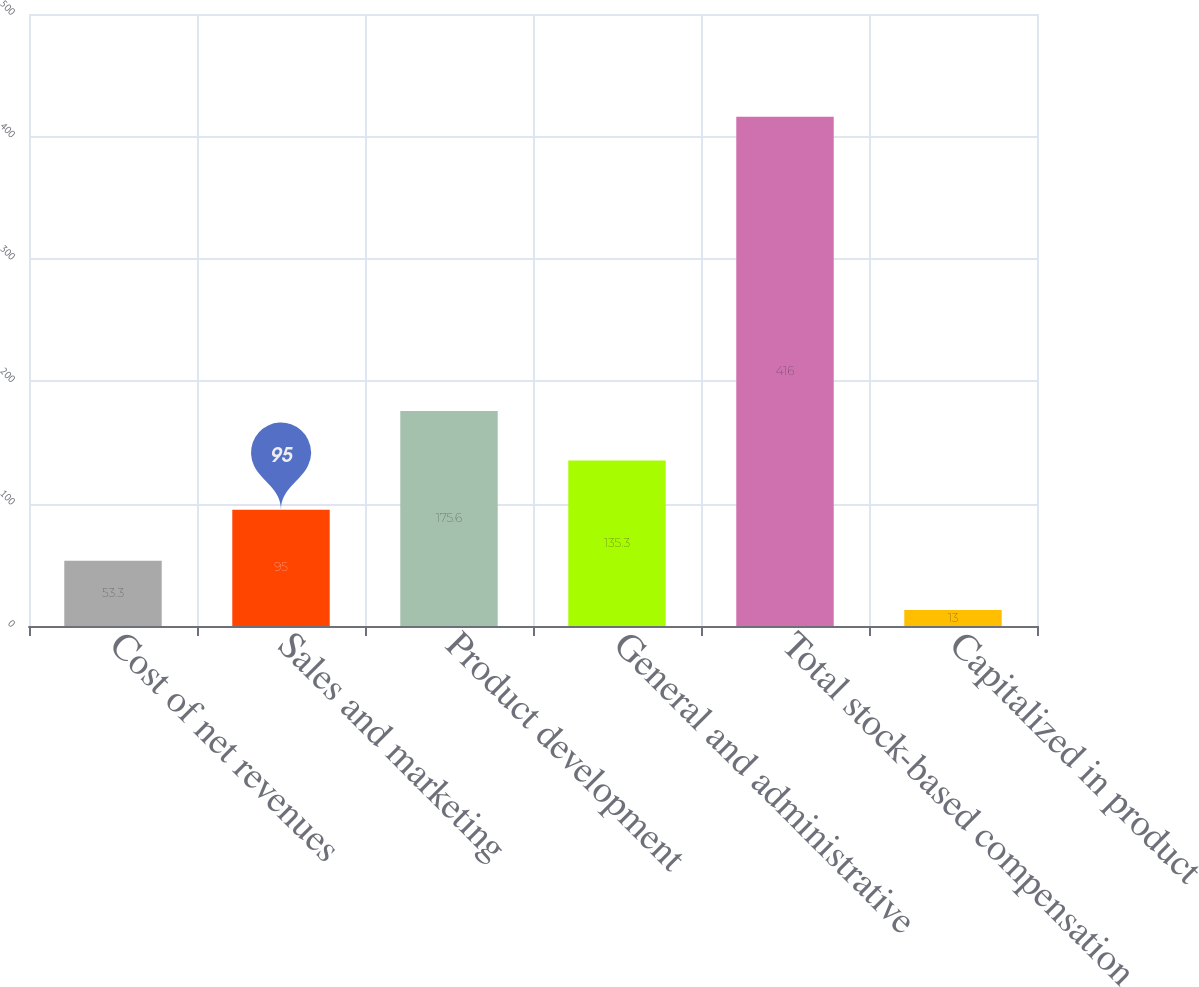Convert chart. <chart><loc_0><loc_0><loc_500><loc_500><bar_chart><fcel>Cost of net revenues<fcel>Sales and marketing<fcel>Product development<fcel>General and administrative<fcel>Total stock-based compensation<fcel>Capitalized in product<nl><fcel>53.3<fcel>95<fcel>175.6<fcel>135.3<fcel>416<fcel>13<nl></chart> 